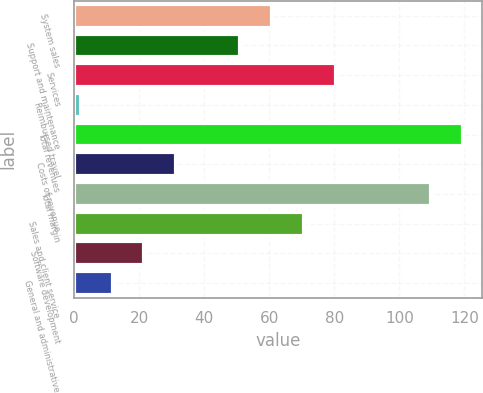<chart> <loc_0><loc_0><loc_500><loc_500><bar_chart><fcel>System sales<fcel>Support and maintenance<fcel>Services<fcel>Reimbursed travel<fcel>Total revenues<fcel>Costs of revenue<fcel>Total margin<fcel>Sales and client service<fcel>Software development<fcel>General and administrative<nl><fcel>60.8<fcel>51<fcel>80.4<fcel>2<fcel>119.6<fcel>31.4<fcel>109.8<fcel>70.6<fcel>21.6<fcel>11.8<nl></chart> 